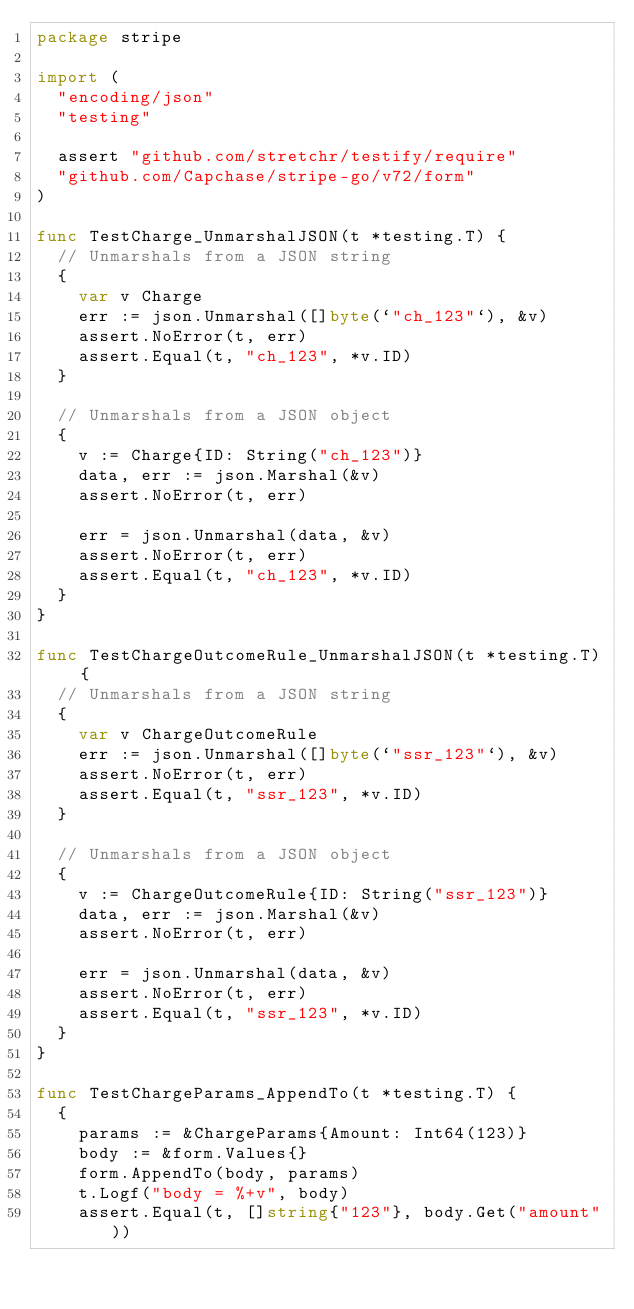Convert code to text. <code><loc_0><loc_0><loc_500><loc_500><_Go_>package stripe

import (
	"encoding/json"
	"testing"

	assert "github.com/stretchr/testify/require"
	"github.com/Capchase/stripe-go/v72/form"
)

func TestCharge_UnmarshalJSON(t *testing.T) {
	// Unmarshals from a JSON string
	{
		var v Charge
		err := json.Unmarshal([]byte(`"ch_123"`), &v)
		assert.NoError(t, err)
		assert.Equal(t, "ch_123", *v.ID)
	}

	// Unmarshals from a JSON object
	{
		v := Charge{ID: String("ch_123")}
		data, err := json.Marshal(&v)
		assert.NoError(t, err)

		err = json.Unmarshal(data, &v)
		assert.NoError(t, err)
		assert.Equal(t, "ch_123", *v.ID)
	}
}

func TestChargeOutcomeRule_UnmarshalJSON(t *testing.T) {
	// Unmarshals from a JSON string
	{
		var v ChargeOutcomeRule
		err := json.Unmarshal([]byte(`"ssr_123"`), &v)
		assert.NoError(t, err)
		assert.Equal(t, "ssr_123", *v.ID)
	}

	// Unmarshals from a JSON object
	{
		v := ChargeOutcomeRule{ID: String("ssr_123")}
		data, err := json.Marshal(&v)
		assert.NoError(t, err)

		err = json.Unmarshal(data, &v)
		assert.NoError(t, err)
		assert.Equal(t, "ssr_123", *v.ID)
	}
}

func TestChargeParams_AppendTo(t *testing.T) {
	{
		params := &ChargeParams{Amount: Int64(123)}
		body := &form.Values{}
		form.AppendTo(body, params)
		t.Logf("body = %+v", body)
		assert.Equal(t, []string{"123"}, body.Get("amount"))</code> 